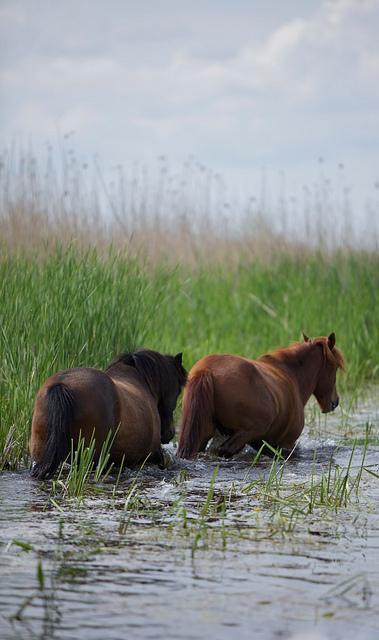How many horses are there?
Give a very brief answer. 2. How many horses are in the picture?
Give a very brief answer. 2. How many of the people sitting have a laptop on there lap?
Give a very brief answer. 0. 